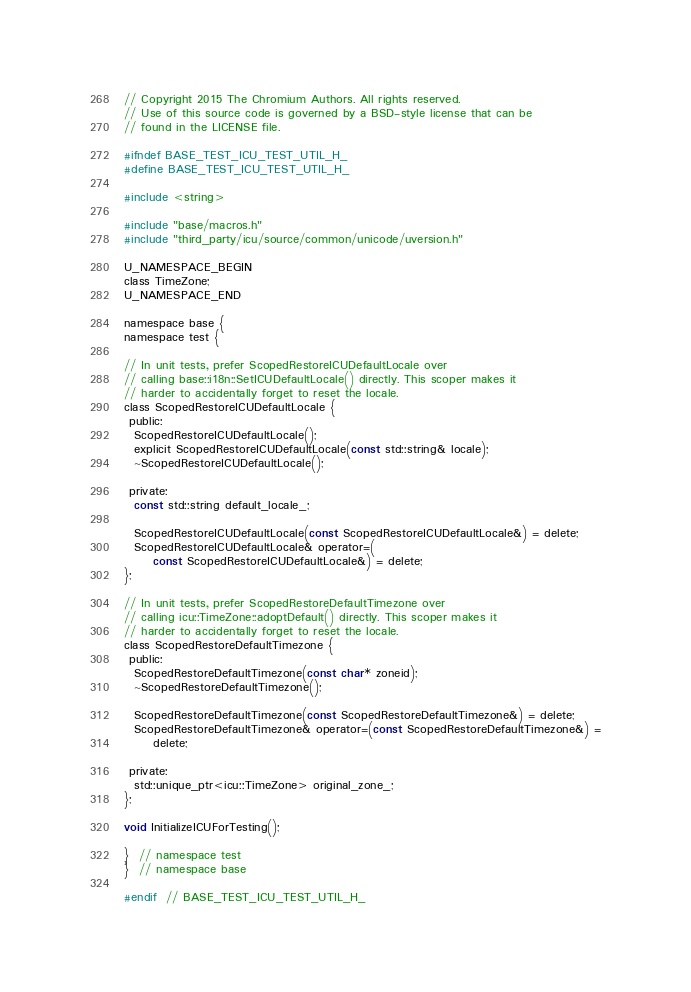<code> <loc_0><loc_0><loc_500><loc_500><_C_>// Copyright 2015 The Chromium Authors. All rights reserved.
// Use of this source code is governed by a BSD-style license that can be
// found in the LICENSE file.

#ifndef BASE_TEST_ICU_TEST_UTIL_H_
#define BASE_TEST_ICU_TEST_UTIL_H_

#include <string>

#include "base/macros.h"
#include "third_party/icu/source/common/unicode/uversion.h"

U_NAMESPACE_BEGIN
class TimeZone;
U_NAMESPACE_END

namespace base {
namespace test {

// In unit tests, prefer ScopedRestoreICUDefaultLocale over
// calling base::i18n::SetICUDefaultLocale() directly. This scoper makes it
// harder to accidentally forget to reset the locale.
class ScopedRestoreICUDefaultLocale {
 public:
  ScopedRestoreICUDefaultLocale();
  explicit ScopedRestoreICUDefaultLocale(const std::string& locale);
  ~ScopedRestoreICUDefaultLocale();

 private:
  const std::string default_locale_;

  ScopedRestoreICUDefaultLocale(const ScopedRestoreICUDefaultLocale&) = delete;
  ScopedRestoreICUDefaultLocale& operator=(
      const ScopedRestoreICUDefaultLocale&) = delete;
};

// In unit tests, prefer ScopedRestoreDefaultTimezone over
// calling icu::TimeZone::adoptDefault() directly. This scoper makes it
// harder to accidentally forget to reset the locale.
class ScopedRestoreDefaultTimezone {
 public:
  ScopedRestoreDefaultTimezone(const char* zoneid);
  ~ScopedRestoreDefaultTimezone();

  ScopedRestoreDefaultTimezone(const ScopedRestoreDefaultTimezone&) = delete;
  ScopedRestoreDefaultTimezone& operator=(const ScopedRestoreDefaultTimezone&) =
      delete;

 private:
  std::unique_ptr<icu::TimeZone> original_zone_;
};

void InitializeICUForTesting();

}  // namespace test
}  // namespace base

#endif  // BASE_TEST_ICU_TEST_UTIL_H_
</code> 